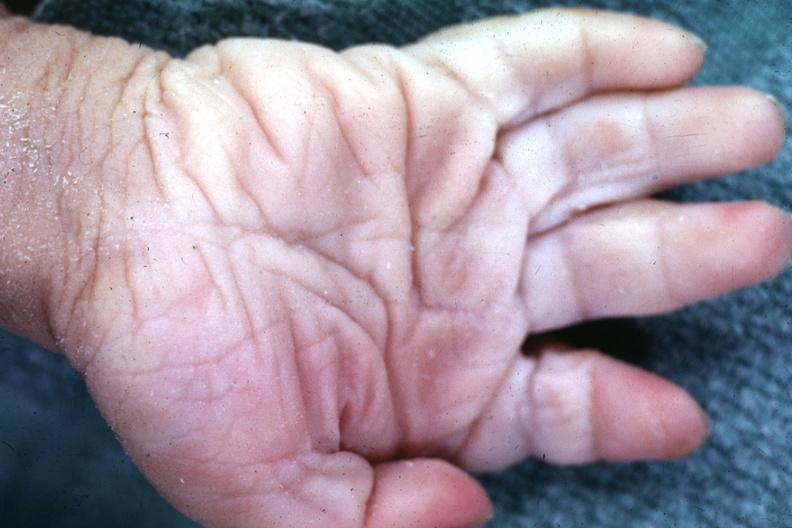what are present?
Answer the question using a single word or phrase. Extremities 